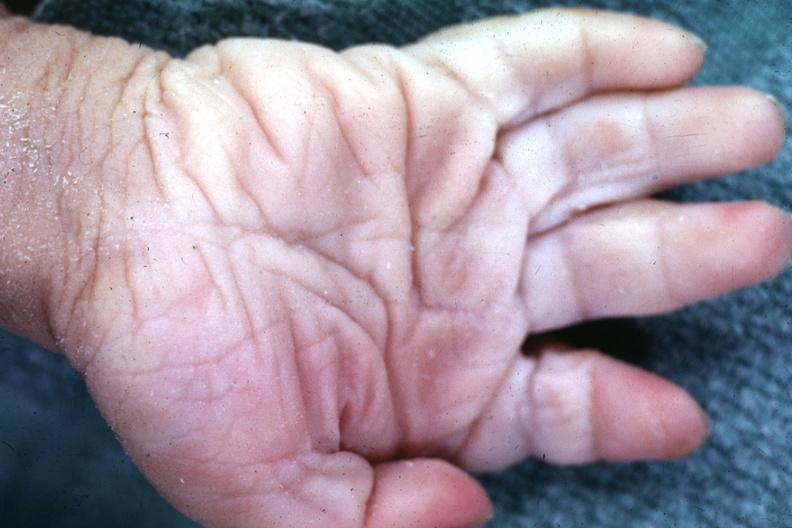what are present?
Answer the question using a single word or phrase. Extremities 